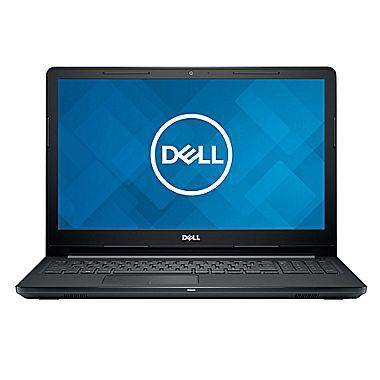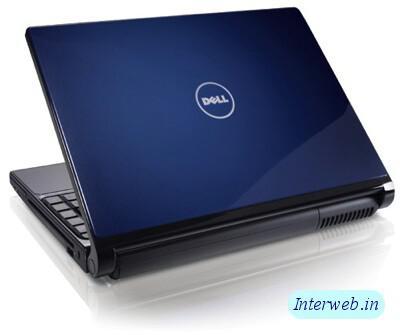The first image is the image on the left, the second image is the image on the right. Given the left and right images, does the statement "All laptops are opened at less than a 90-degree angle, and at least one laptop has its back turned toward the camera." hold true? Answer yes or no. No. The first image is the image on the left, the second image is the image on the right. For the images displayed, is the sentence "One of images shows a laptop with the keyboard facing forward and the other image shows a laptop with the keyboard at an angle." factually correct? Answer yes or no. Yes. 